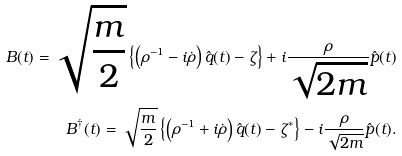<formula> <loc_0><loc_0><loc_500><loc_500>B ( t ) = \sqrt { \frac { m } { 2 } } \left \{ \left ( \rho ^ { - 1 } - i \dot { \rho } \right ) \hat { q } ( t ) - \zeta \right \} + i \frac { \rho } { \sqrt { 2 m } } \hat { p } ( t ) \\ B ^ { \dagger } ( t ) = \sqrt { \frac { m } { 2 } } \left \{ \left ( \rho ^ { - 1 } + i \dot { \rho } \right ) \hat { q } ( t ) - \zeta ^ { * } \right \} - i \frac { \rho } { \sqrt { 2 m } } \hat { p } ( t ) .</formula> 